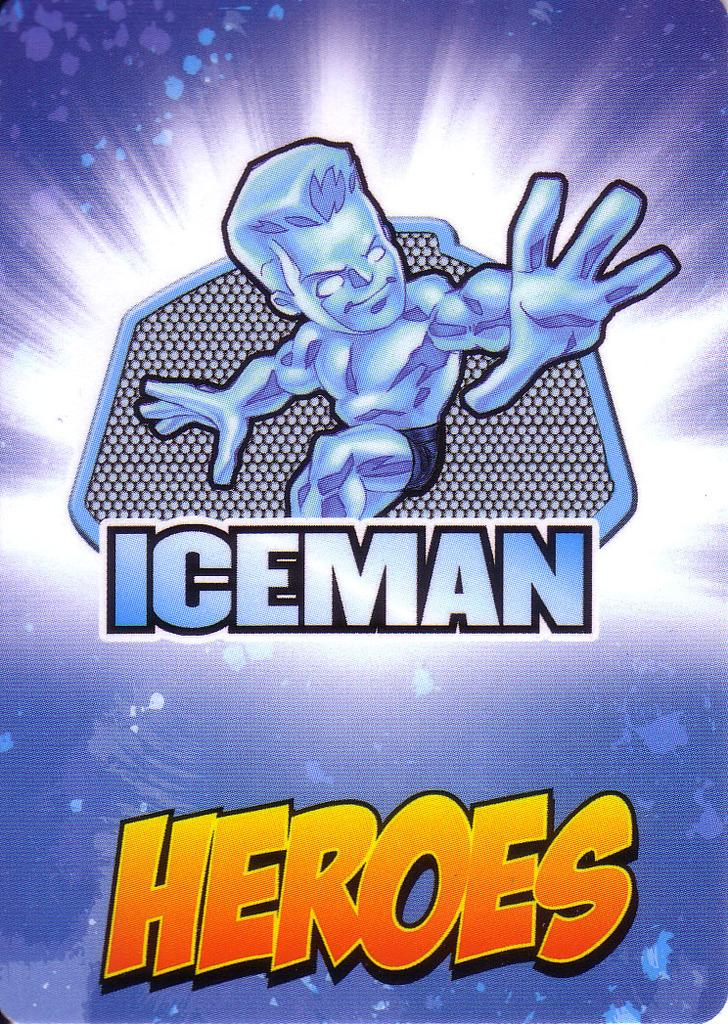Provide a one-sentence caption for the provided image. A blue and yellow cartoon image pertains to Iceman Heroes. 